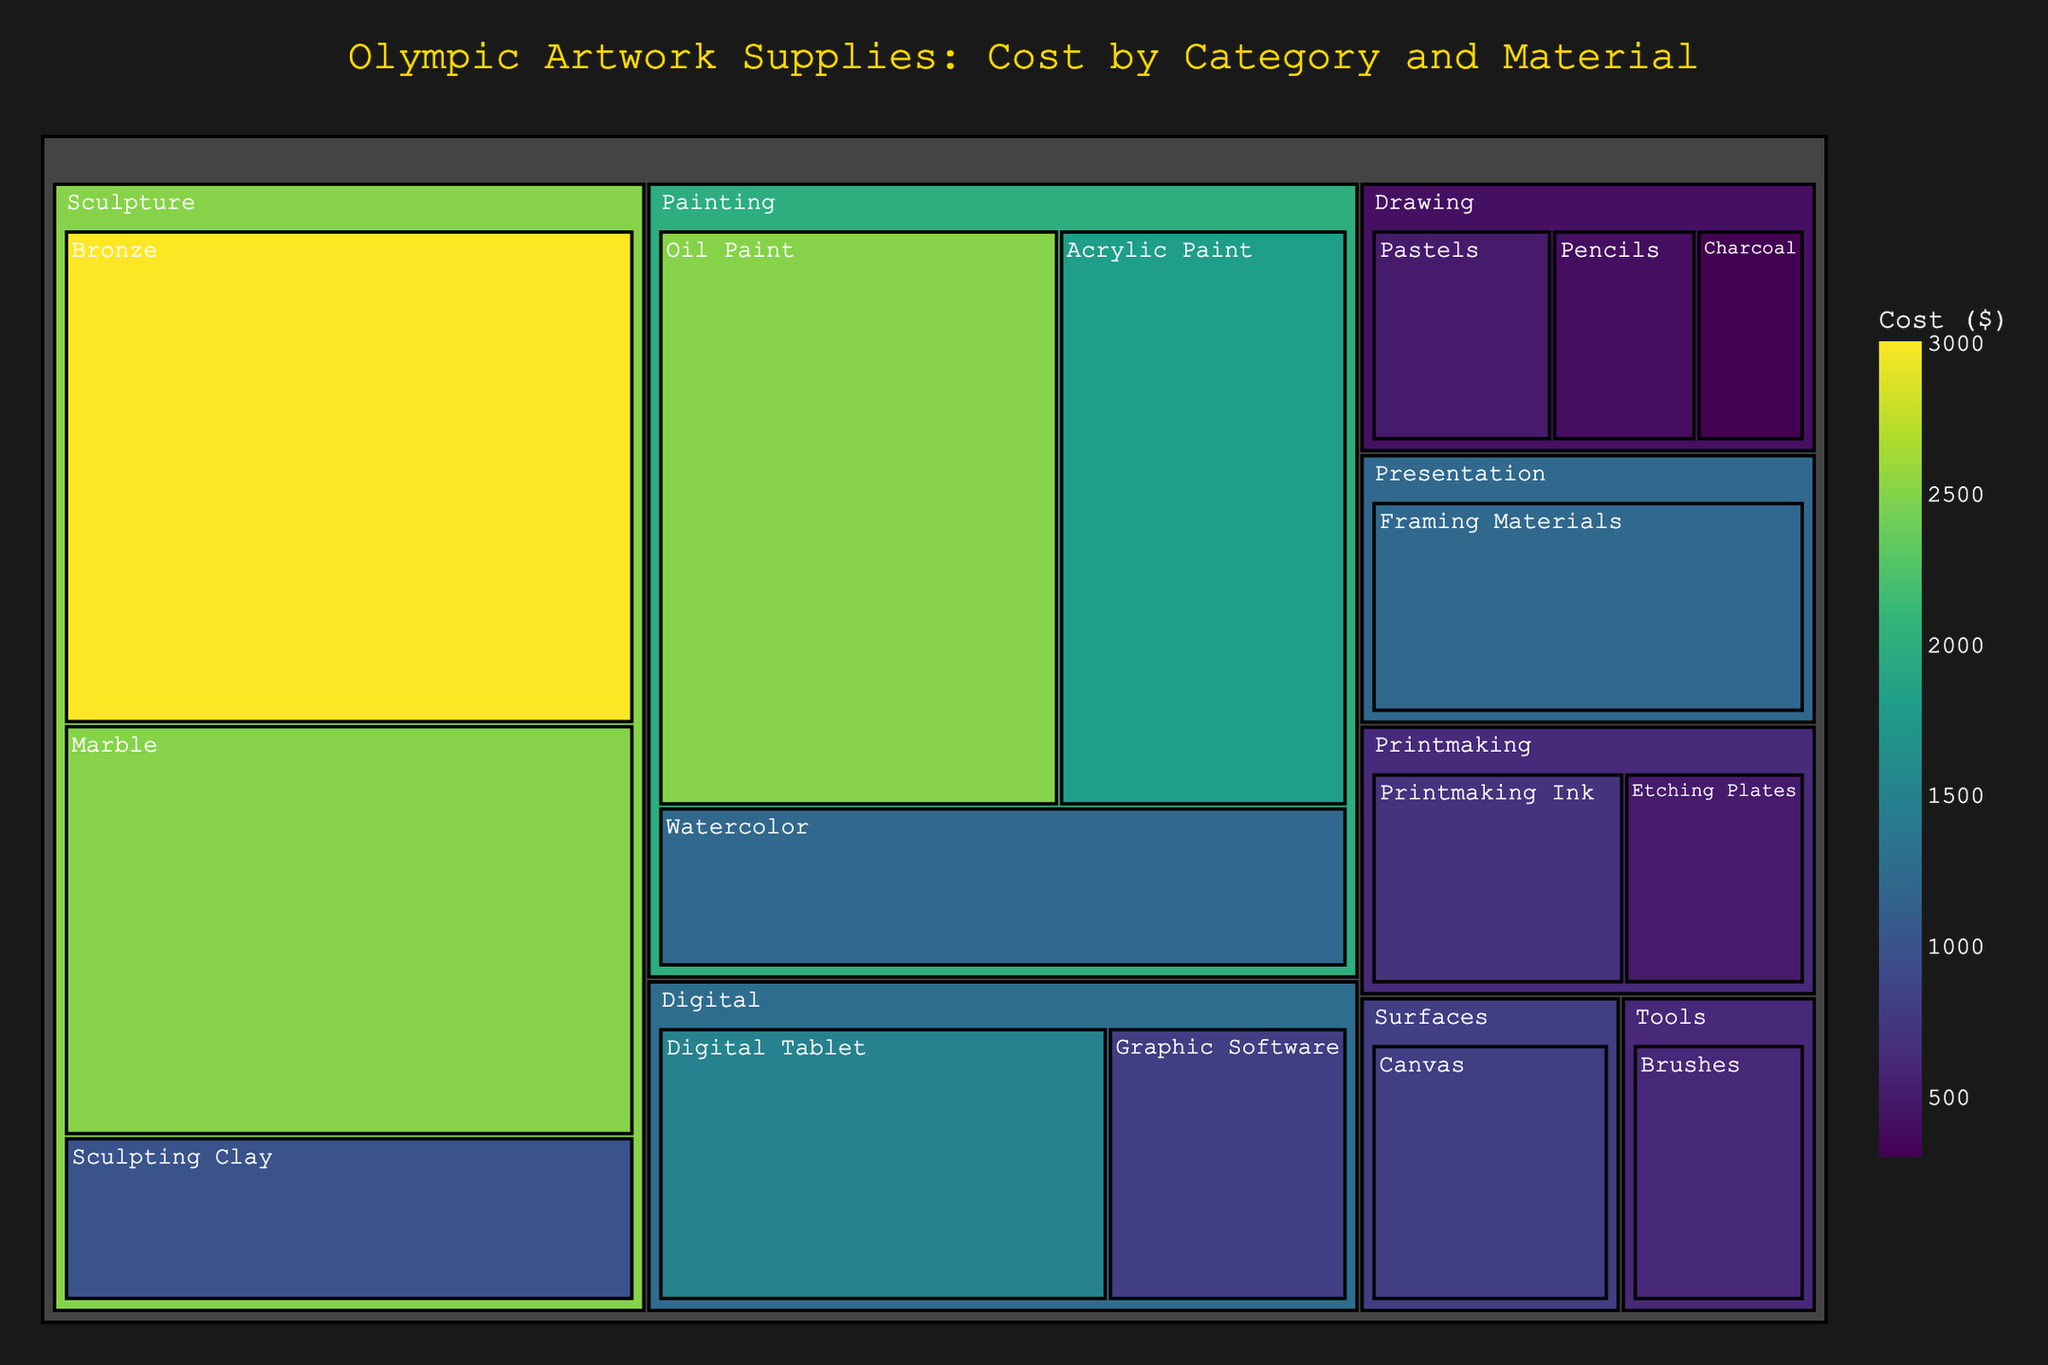What's the most expensive material in the "Sculpture" category? The "Sculpture" category contains Sculpting Clay, Bronze, and Marble. From the treemap, Bronze has the highest cost in this category.
Answer: Bronze Which category has the highest overall cost? To find the category with the highest overall cost, compare the total costs of each category. The "Painting" category, represented by larger and brighter colored blocks, has the highest overall cost.
Answer: Painting What's the combined cost of all materials in the "Digital" category? The "Digital" category includes Digital Tablet ($1500) and Graphic Software ($800). Summing these amounts gives us $1500 + $800 = $2300.
Answer: $2300 How does the cost of "Acrylic Paint" compare to "Oil Paint"? "Acrylic Paint" has a cost of $1800, while "Oil Paint" costs $2500. Therefore, "Oil Paint" is more expensive than "Acrylic Paint".
Answer: Oil Paint is more expensive What's the difference in cost between the least expensive and most expensive materials in the "Drawing" category? The "Drawing" category contains Pencils ($400), Charcoal ($300), and Pastels ($500). The most expensive is Pastels ($500) and the least expensive is Charcoal ($300). The difference is $500 - $300 = $200.
Answer: $200 What percentage of the total cost is contributed by the "Presentation" category? Calculate the total cost of all categories first. Sum is $2500 (Oil Paint) + $1800 (Acrylic Paint) + $1200 (Watercolor) + $800 (Canvas) + $600 (Brushes) + $400 (Pencils) + $300 (Charcoal) + $500 (Pastels) + $1000 (Sculpting Clay) + $3000 (Bronze) + $2500 (Marble) + $1500 (Digital Tablet) + $800 (Graphic Software) + $700 (Printmaking Ink) + $500 (Etching Plates) + $1200 (Framing Materials) = $19100. The cost of the "Presentation" category is $1200. So the percentage is ($1200 / $19100) * 100 ≈ 6.28%.
Answer: 6.28% Which category has the most number of distinct materials? The treemap shows the number of distinct materials within each category as separate blocks. "Drawing" has three distinct materials: Pencils, Charcoal, and Pastels. Most other categories have fewer materials.
Answer: Drawing What's the cost of the least expensive material in the "Painting" category? The "Painting" category includes Oil Paint ($2500), Acrylic Paint ($1800), and Watercolor ($1200). The least expensive material here is Watercolor.
Answer: Watercolor 